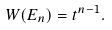<formula> <loc_0><loc_0><loc_500><loc_500>W ( E _ { n } ) = t ^ { n - 1 } .</formula> 